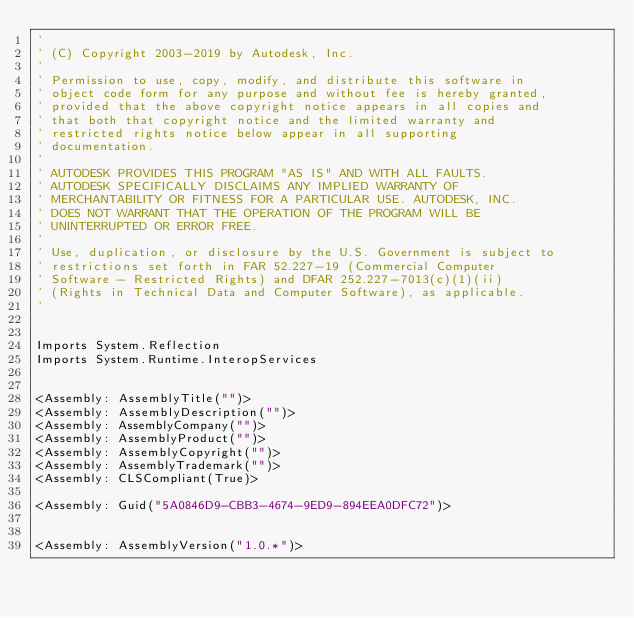Convert code to text. <code><loc_0><loc_0><loc_500><loc_500><_VisualBasic_>'
' (C) Copyright 2003-2019 by Autodesk, Inc.
'
' Permission to use, copy, modify, and distribute this software in
' object code form for any purpose and without fee is hereby granted,
' provided that the above copyright notice appears in all copies and
' that both that copyright notice and the limited warranty and
' restricted rights notice below appear in all supporting
' documentation.
'
' AUTODESK PROVIDES THIS PROGRAM "AS IS" AND WITH ALL FAULTS.
' AUTODESK SPECIFICALLY DISCLAIMS ANY IMPLIED WARRANTY OF
' MERCHANTABILITY OR FITNESS FOR A PARTICULAR USE. AUTODESK, INC.
' DOES NOT WARRANT THAT THE OPERATION OF THE PROGRAM WILL BE
' UNINTERRUPTED OR ERROR FREE.
'
' Use, duplication, or disclosure by the U.S. Government is subject to
' restrictions set forth in FAR 52.227-19 (Commercial Computer
' Software - Restricted Rights) and DFAR 252.227-7013(c)(1)(ii)
' (Rights in Technical Data and Computer Software), as applicable.
'


Imports System.Reflection
Imports System.Runtime.InteropServices


<Assembly: AssemblyTitle("")> 
<Assembly: AssemblyDescription("")> 
<Assembly: AssemblyCompany("")> 
<Assembly: AssemblyProduct("")> 
<Assembly: AssemblyCopyright("")> 
<Assembly: AssemblyTrademark("")> 
<Assembly: CLSCompliant(True)> 

<Assembly: Guid("5A0846D9-CBB3-4674-9ED9-894EEA0DFC72")> 


<Assembly: AssemblyVersion("1.0.*")> 
</code> 